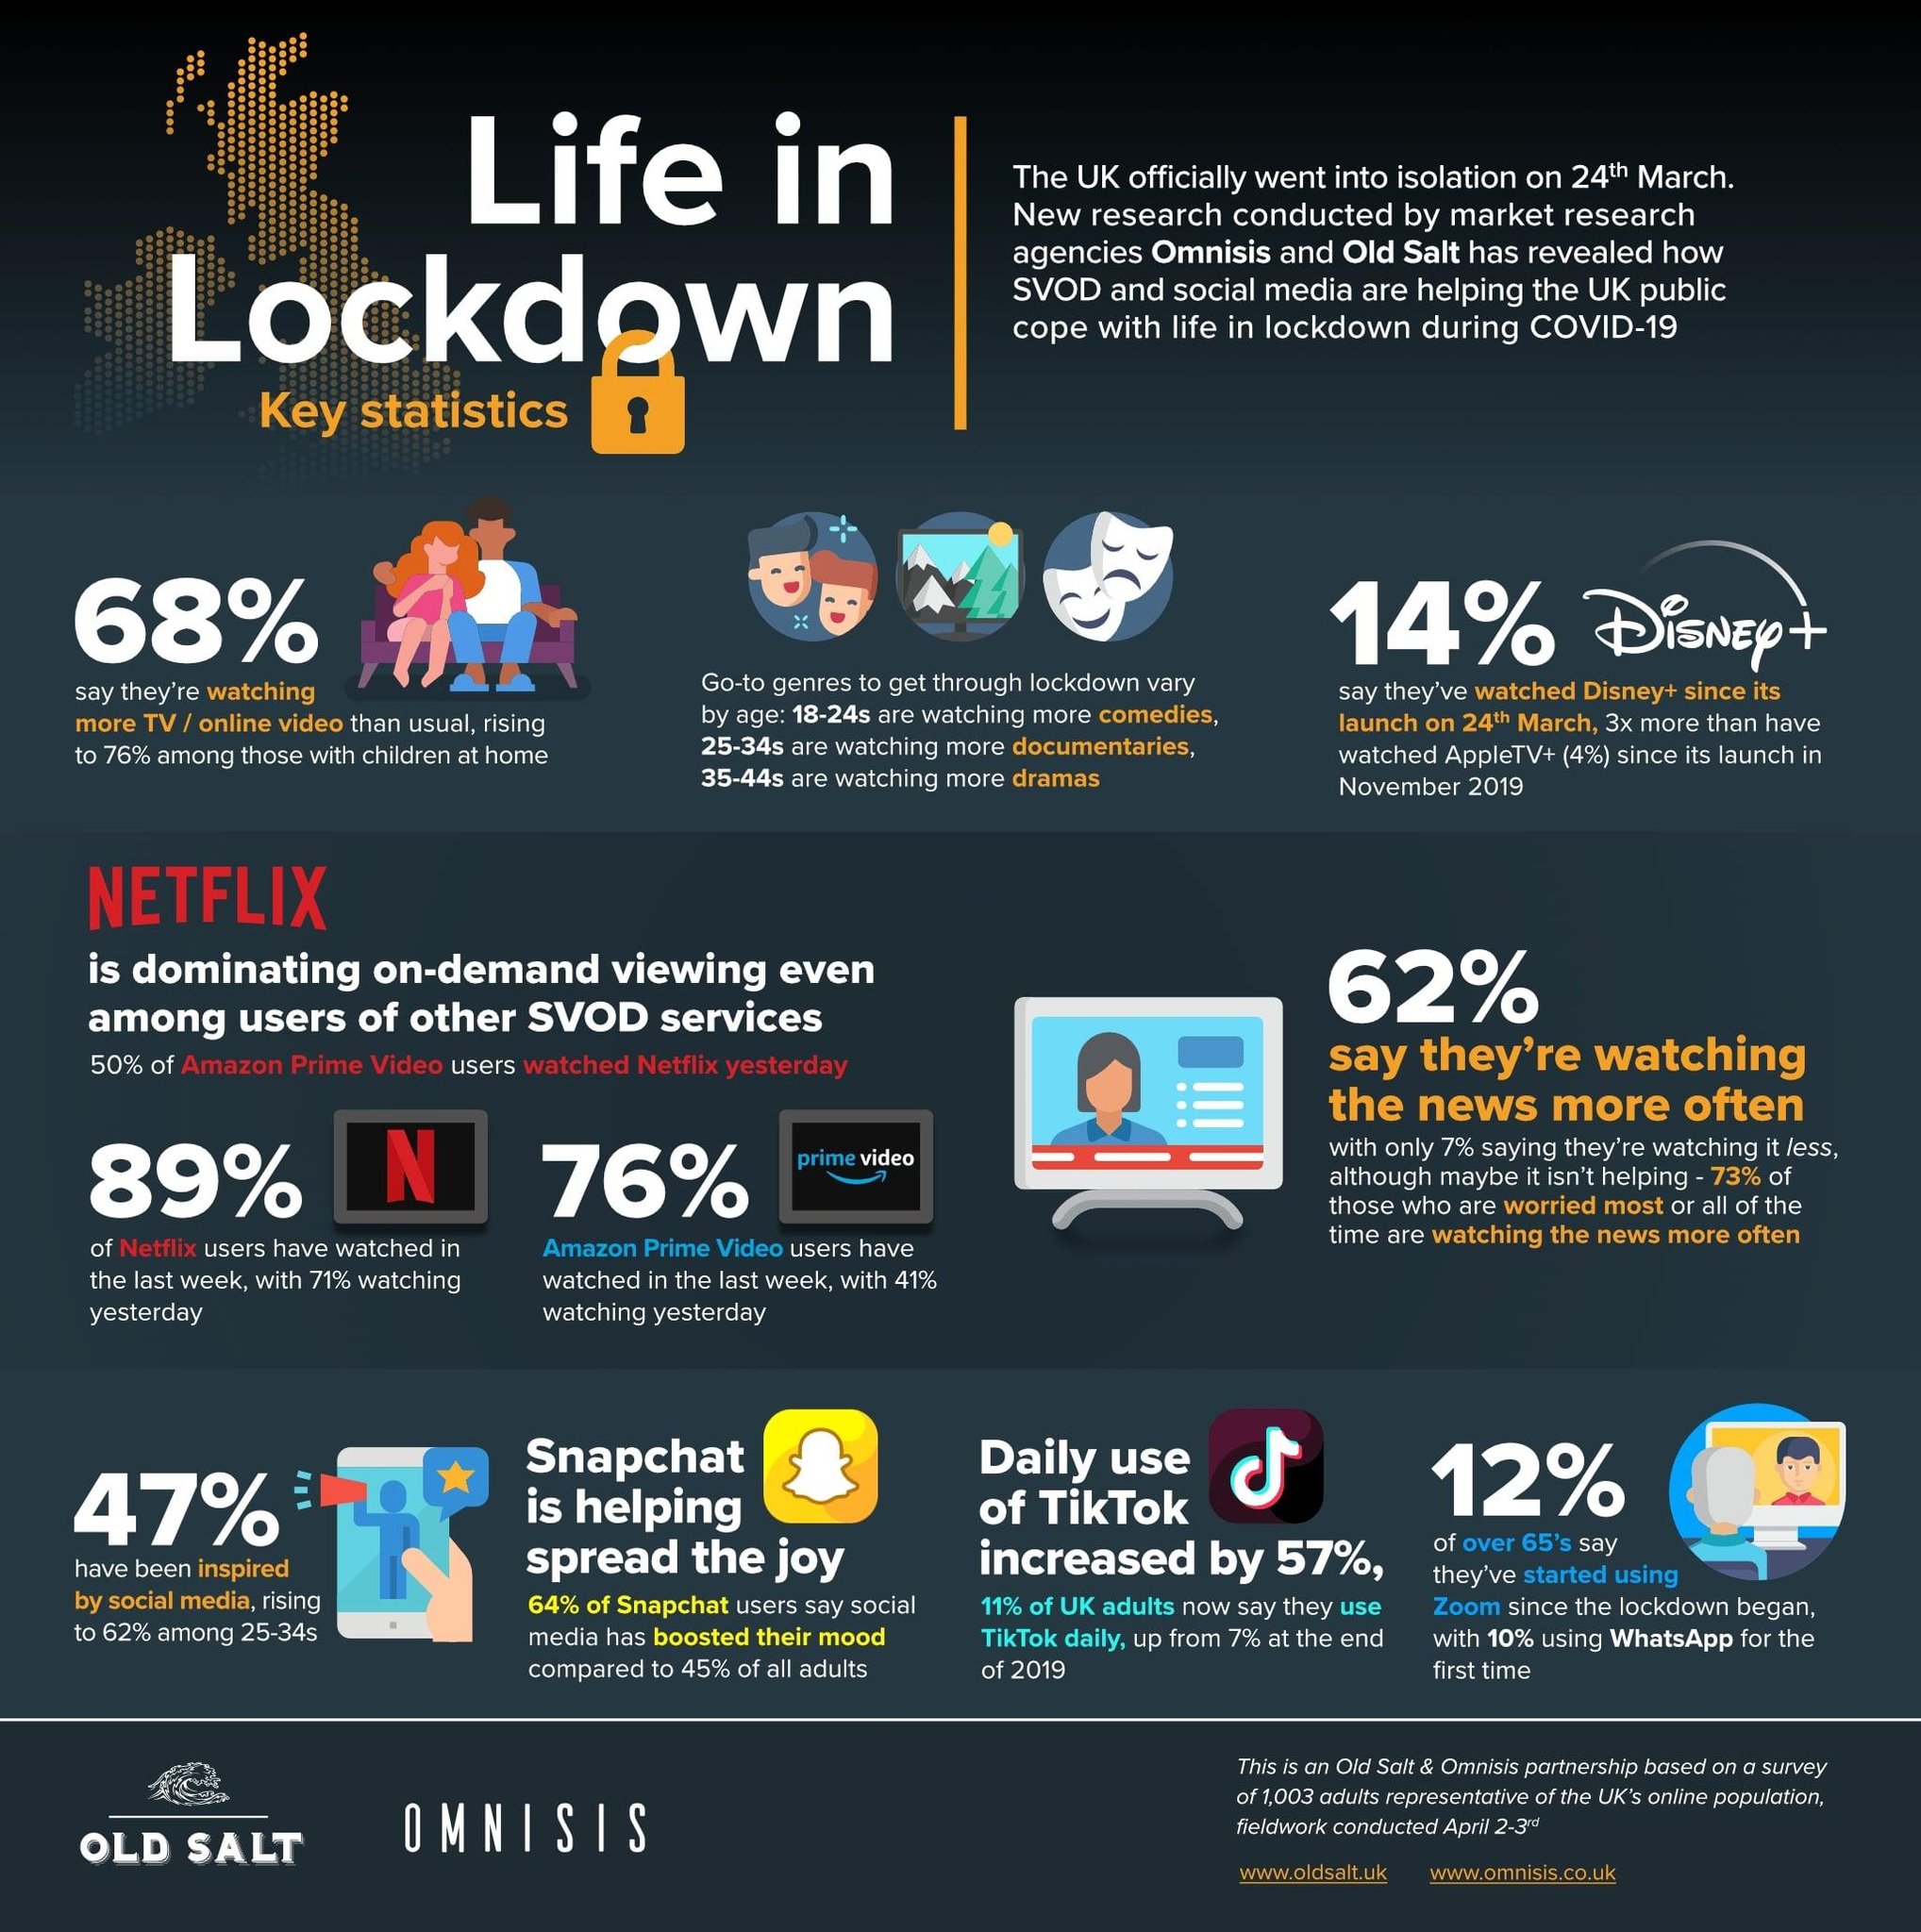List a handful of essential elements in this visual. The increase in TikTok from 2019 has been 7%. According to the survey, 62% of the respondents reported that they watch the news more often than before. According to recent data, approximately 12% of senior citizens have started using Zoom. The viewership of Disney has increased by three times when compared to AppleTV. 